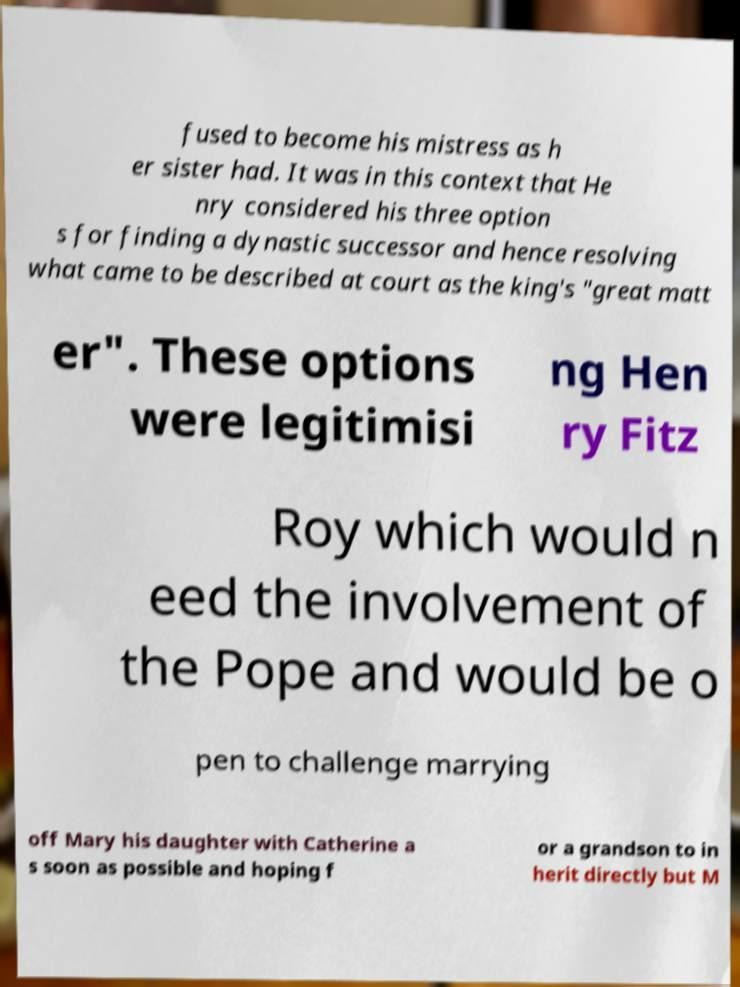Can you read and provide the text displayed in the image?This photo seems to have some interesting text. Can you extract and type it out for me? fused to become his mistress as h er sister had. It was in this context that He nry considered his three option s for finding a dynastic successor and hence resolving what came to be described at court as the king's "great matt er". These options were legitimisi ng Hen ry Fitz Roy which would n eed the involvement of the Pope and would be o pen to challenge marrying off Mary his daughter with Catherine a s soon as possible and hoping f or a grandson to in herit directly but M 